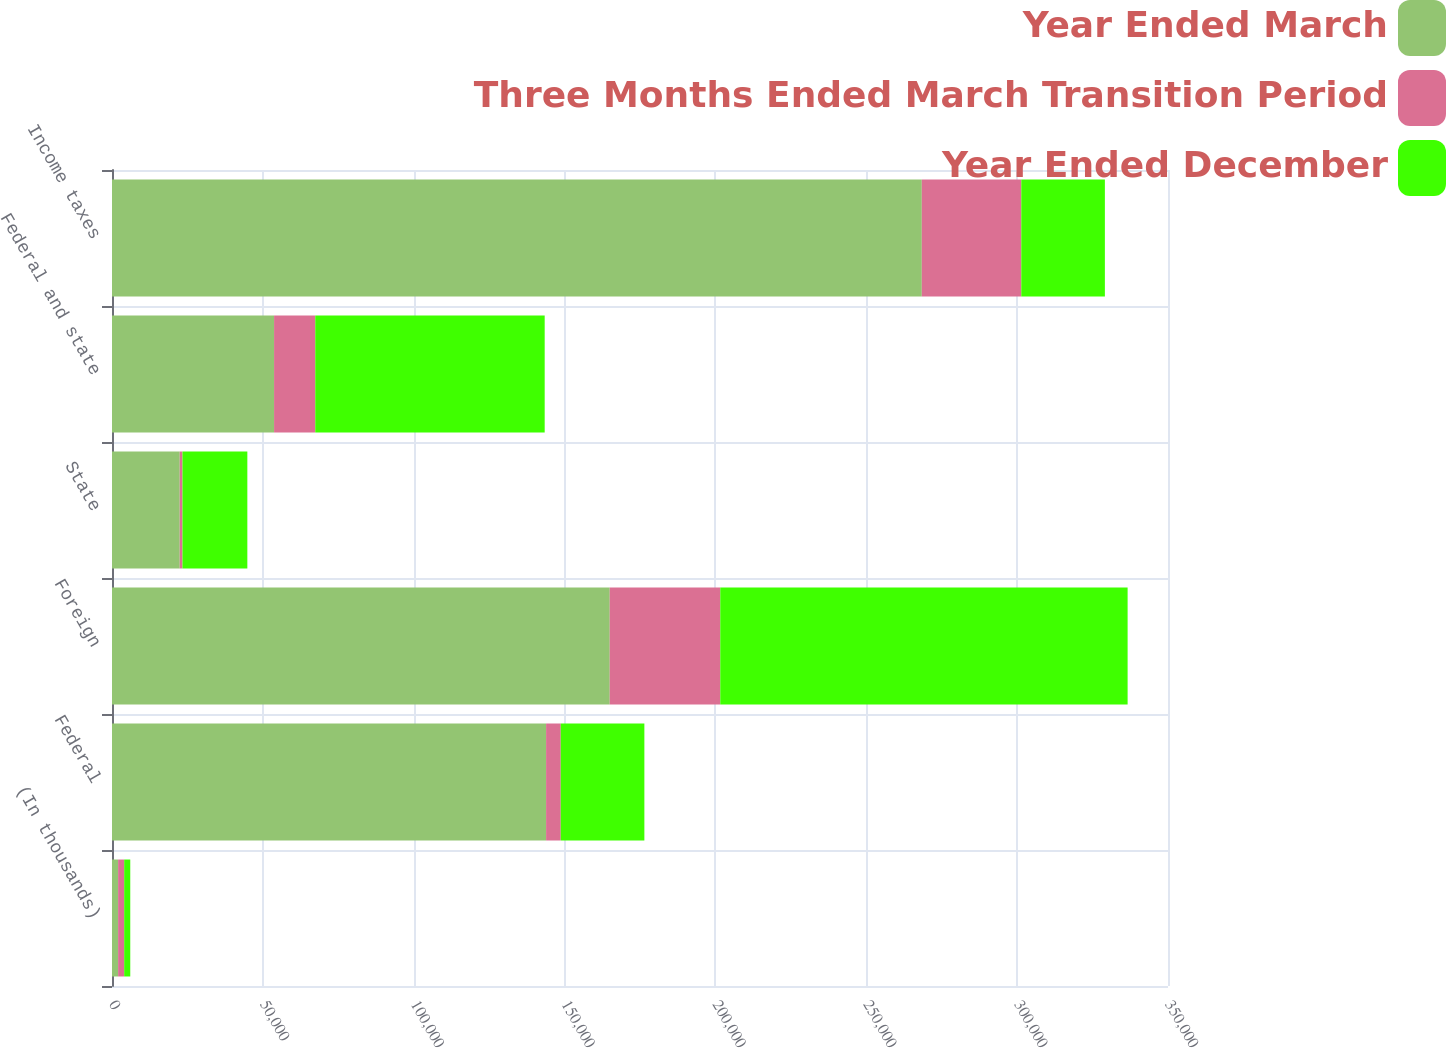Convert chart. <chart><loc_0><loc_0><loc_500><loc_500><stacked_bar_chart><ecel><fcel>(In thousands)<fcel>Federal<fcel>Foreign<fcel>State<fcel>Federal and state<fcel>Income taxes<nl><fcel>Year Ended March<fcel>2019<fcel>143872<fcel>164974<fcel>22455<fcel>53715<fcel>268400<nl><fcel>Three Months Ended March Transition Period<fcel>2018<fcel>4864<fcel>36634<fcel>896<fcel>13656<fcel>32969<nl><fcel>Year Ended December<fcel>2017<fcel>27712<fcel>135007<fcel>21506<fcel>76039<fcel>27712<nl></chart> 